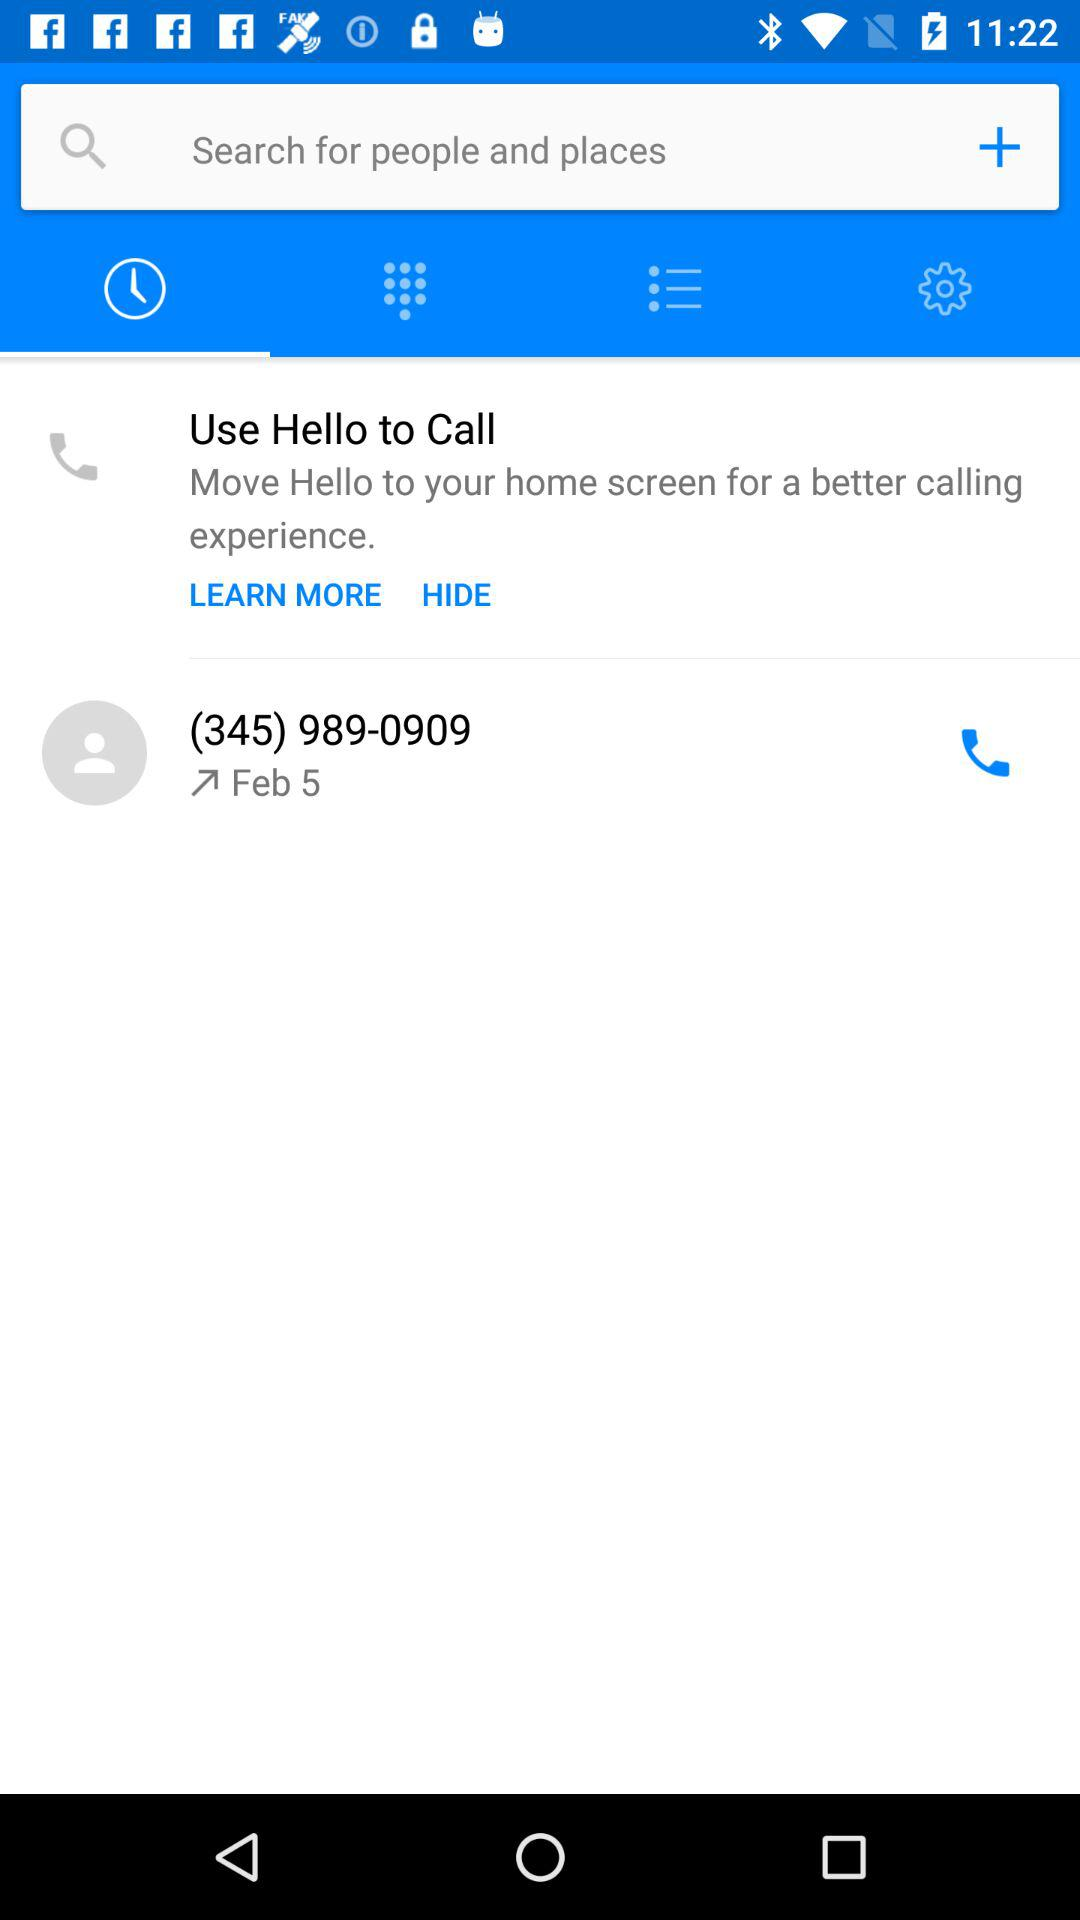What is the phone number? The phone number is (345) 989-0909. 